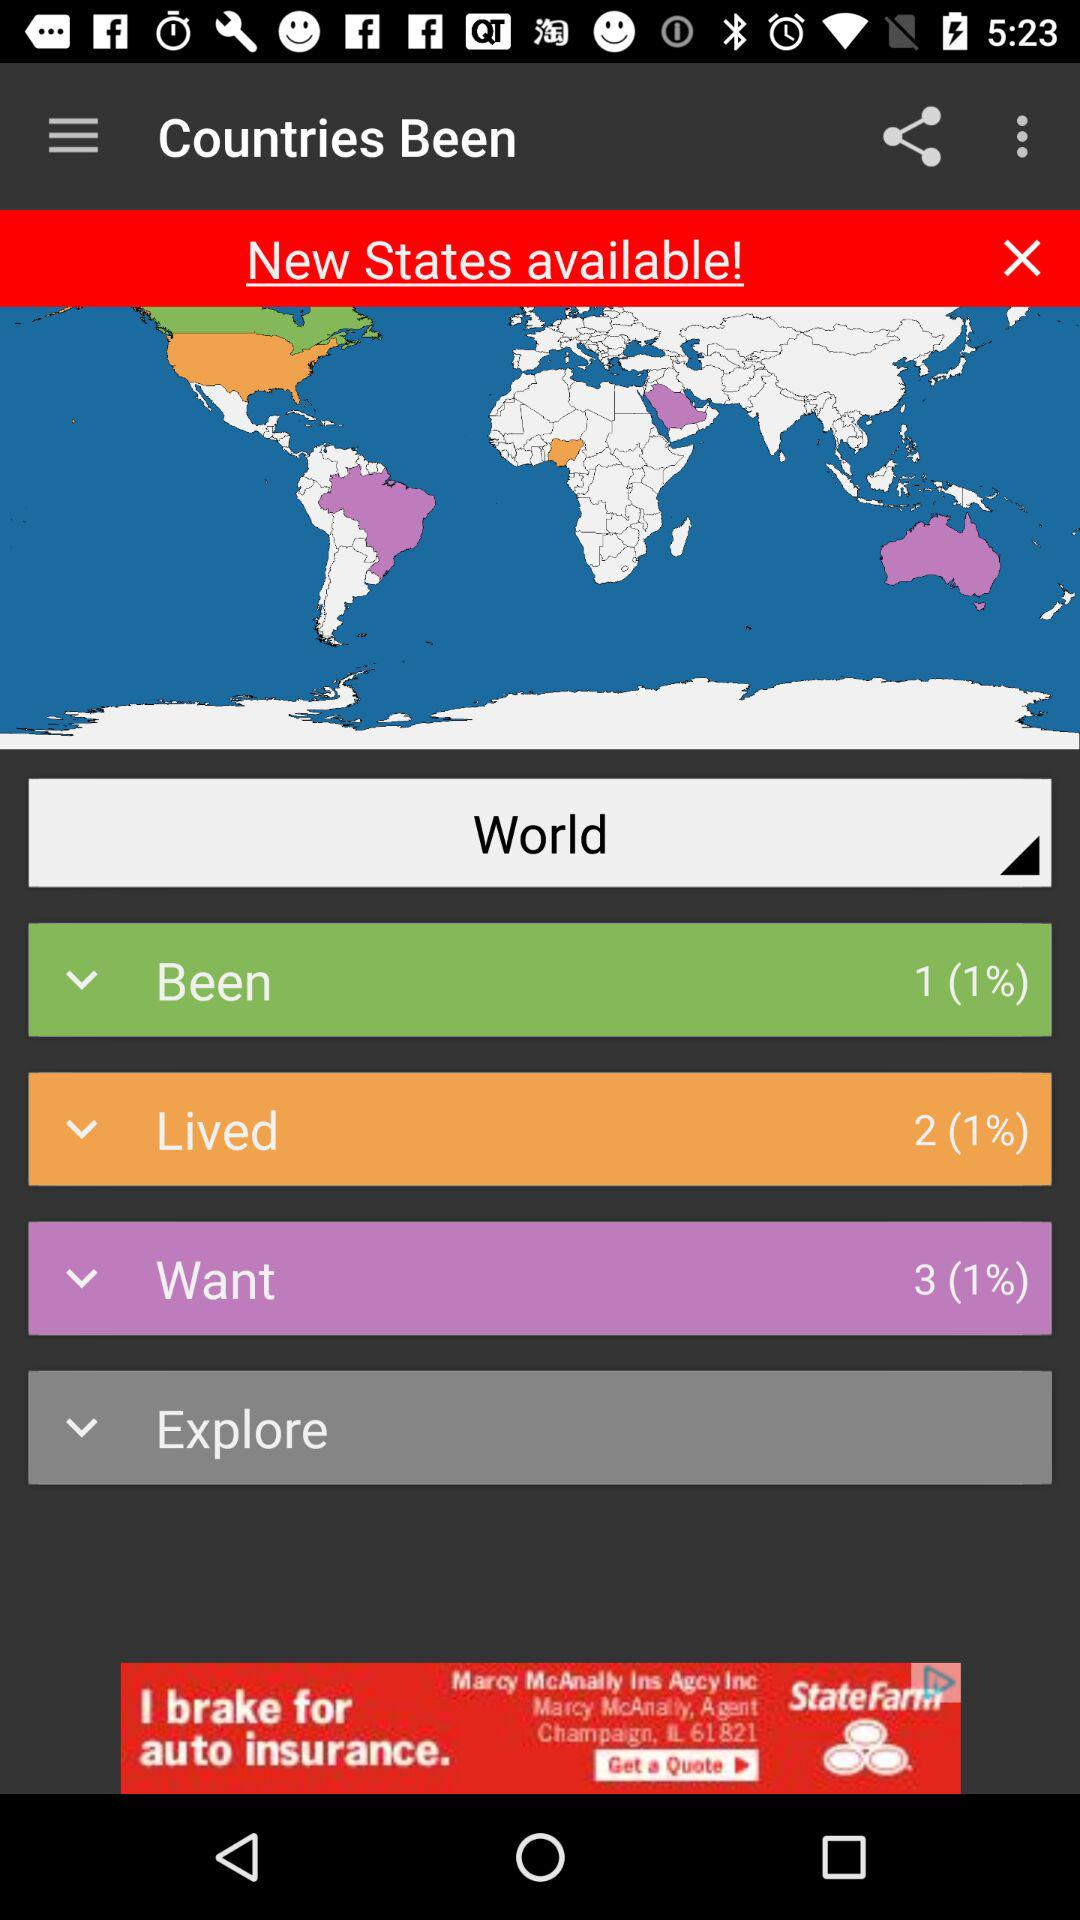How many more countries have I been to than lived in?
Answer the question using a single word or phrase. 1 